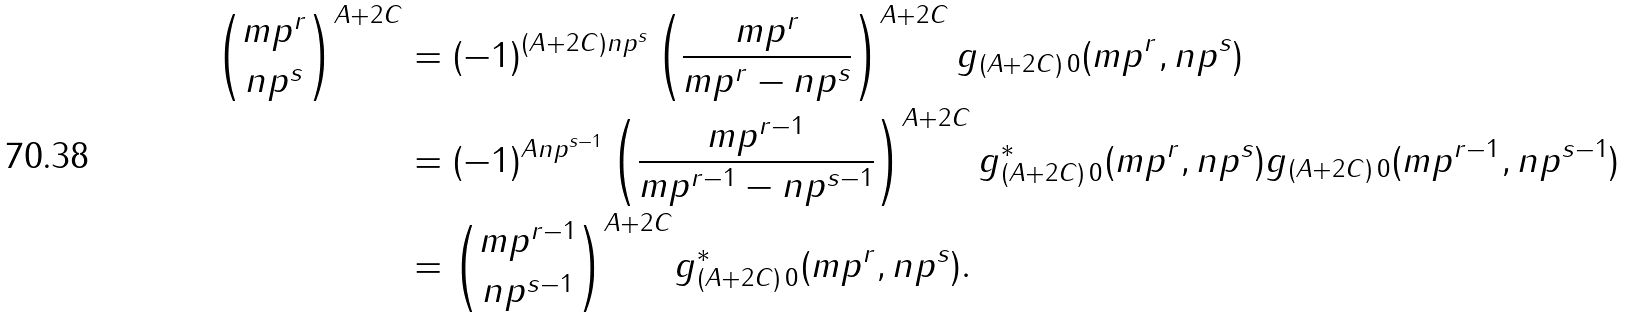Convert formula to latex. <formula><loc_0><loc_0><loc_500><loc_500>\binom { m p ^ { r } } { n p ^ { s } } ^ { A + 2 C } & = ( - 1 ) ^ { ( A + 2 C ) n p ^ { s } } \left ( \frac { m p ^ { r } } { m p ^ { r } - n p ^ { s } } \right ) ^ { A + 2 C } g _ { ( A + 2 C ) \, 0 } ( m p ^ { r } , n p ^ { s } ) \\ & = ( - 1 ) ^ { A n p ^ { s - 1 } } \left ( \frac { m p ^ { r - 1 } } { m p ^ { r - 1 } - n p ^ { s - 1 } } \right ) ^ { A + 2 C } g _ { ( A + 2 C ) \, 0 } ^ { * } ( m p ^ { r } , n p ^ { s } ) g _ { ( A + 2 C ) \, 0 } ( m p ^ { r - 1 } , n p ^ { s - 1 } ) \\ & = \binom { m p ^ { r - 1 } } { n p ^ { s - 1 } } ^ { A + 2 C } g _ { ( A + 2 C ) \, 0 } ^ { * } ( m p ^ { r } , n p ^ { s } ) .</formula> 